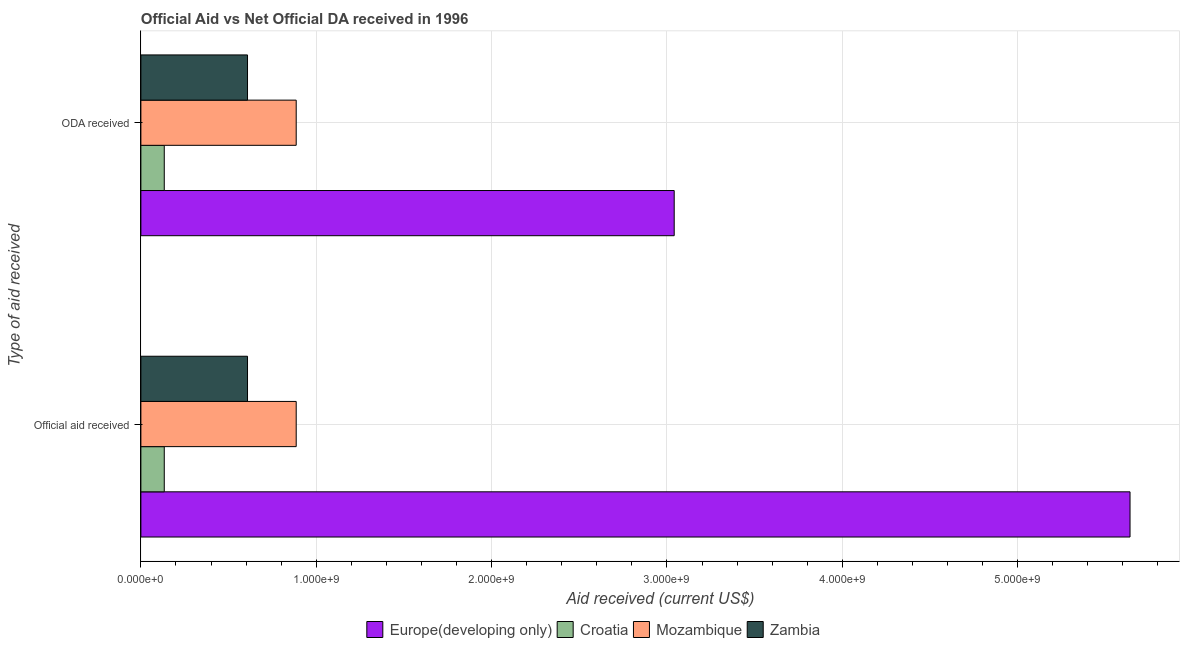How many different coloured bars are there?
Give a very brief answer. 4. Are the number of bars per tick equal to the number of legend labels?
Ensure brevity in your answer.  Yes. Are the number of bars on each tick of the Y-axis equal?
Ensure brevity in your answer.  Yes. How many bars are there on the 1st tick from the top?
Provide a short and direct response. 4. What is the label of the 1st group of bars from the top?
Offer a terse response. ODA received. What is the oda received in Croatia?
Provide a succinct answer. 1.33e+08. Across all countries, what is the maximum official aid received?
Keep it short and to the point. 5.64e+09. Across all countries, what is the minimum official aid received?
Provide a short and direct response. 1.33e+08. In which country was the official aid received maximum?
Your answer should be compact. Europe(developing only). In which country was the oda received minimum?
Provide a succinct answer. Croatia. What is the total official aid received in the graph?
Offer a terse response. 7.27e+09. What is the difference between the official aid received in Europe(developing only) and that in Zambia?
Keep it short and to the point. 5.03e+09. What is the difference between the oda received in Zambia and the official aid received in Croatia?
Your answer should be compact. 4.75e+08. What is the average oda received per country?
Your answer should be compact. 1.17e+09. In how many countries, is the oda received greater than 400000000 US$?
Make the answer very short. 3. What is the ratio of the oda received in Zambia to that in Europe(developing only)?
Your response must be concise. 0.2. Is the oda received in Croatia less than that in Mozambique?
Offer a terse response. Yes. What does the 2nd bar from the top in ODA received represents?
Your answer should be compact. Mozambique. What does the 1st bar from the bottom in ODA received represents?
Ensure brevity in your answer.  Europe(developing only). How many bars are there?
Make the answer very short. 8. Are the values on the major ticks of X-axis written in scientific E-notation?
Your answer should be compact. Yes. Does the graph contain any zero values?
Your response must be concise. No. Where does the legend appear in the graph?
Offer a very short reply. Bottom center. What is the title of the graph?
Provide a succinct answer. Official Aid vs Net Official DA received in 1996 . Does "Timor-Leste" appear as one of the legend labels in the graph?
Offer a terse response. No. What is the label or title of the X-axis?
Make the answer very short. Aid received (current US$). What is the label or title of the Y-axis?
Provide a short and direct response. Type of aid received. What is the Aid received (current US$) in Europe(developing only) in Official aid received?
Make the answer very short. 5.64e+09. What is the Aid received (current US$) of Croatia in Official aid received?
Provide a succinct answer. 1.33e+08. What is the Aid received (current US$) in Mozambique in Official aid received?
Make the answer very short. 8.86e+08. What is the Aid received (current US$) of Zambia in Official aid received?
Provide a succinct answer. 6.08e+08. What is the Aid received (current US$) in Europe(developing only) in ODA received?
Ensure brevity in your answer.  3.04e+09. What is the Aid received (current US$) of Croatia in ODA received?
Provide a short and direct response. 1.33e+08. What is the Aid received (current US$) in Mozambique in ODA received?
Give a very brief answer. 8.86e+08. What is the Aid received (current US$) in Zambia in ODA received?
Provide a succinct answer. 6.08e+08. Across all Type of aid received, what is the maximum Aid received (current US$) in Europe(developing only)?
Ensure brevity in your answer.  5.64e+09. Across all Type of aid received, what is the maximum Aid received (current US$) of Croatia?
Give a very brief answer. 1.33e+08. Across all Type of aid received, what is the maximum Aid received (current US$) in Mozambique?
Your answer should be compact. 8.86e+08. Across all Type of aid received, what is the maximum Aid received (current US$) of Zambia?
Offer a very short reply. 6.08e+08. Across all Type of aid received, what is the minimum Aid received (current US$) of Europe(developing only)?
Make the answer very short. 3.04e+09. Across all Type of aid received, what is the minimum Aid received (current US$) of Croatia?
Offer a terse response. 1.33e+08. Across all Type of aid received, what is the minimum Aid received (current US$) in Mozambique?
Provide a succinct answer. 8.86e+08. Across all Type of aid received, what is the minimum Aid received (current US$) of Zambia?
Your response must be concise. 6.08e+08. What is the total Aid received (current US$) of Europe(developing only) in the graph?
Offer a very short reply. 8.68e+09. What is the total Aid received (current US$) of Croatia in the graph?
Offer a very short reply. 2.67e+08. What is the total Aid received (current US$) of Mozambique in the graph?
Provide a succinct answer. 1.77e+09. What is the total Aid received (current US$) of Zambia in the graph?
Your answer should be very brief. 1.22e+09. What is the difference between the Aid received (current US$) in Europe(developing only) in Official aid received and that in ODA received?
Give a very brief answer. 2.60e+09. What is the difference between the Aid received (current US$) of Croatia in Official aid received and that in ODA received?
Provide a succinct answer. 0. What is the difference between the Aid received (current US$) in Mozambique in Official aid received and that in ODA received?
Your answer should be compact. 0. What is the difference between the Aid received (current US$) in Europe(developing only) in Official aid received and the Aid received (current US$) in Croatia in ODA received?
Offer a very short reply. 5.51e+09. What is the difference between the Aid received (current US$) in Europe(developing only) in Official aid received and the Aid received (current US$) in Mozambique in ODA received?
Your response must be concise. 4.76e+09. What is the difference between the Aid received (current US$) of Europe(developing only) in Official aid received and the Aid received (current US$) of Zambia in ODA received?
Give a very brief answer. 5.03e+09. What is the difference between the Aid received (current US$) of Croatia in Official aid received and the Aid received (current US$) of Mozambique in ODA received?
Provide a short and direct response. -7.52e+08. What is the difference between the Aid received (current US$) in Croatia in Official aid received and the Aid received (current US$) in Zambia in ODA received?
Provide a short and direct response. -4.75e+08. What is the difference between the Aid received (current US$) of Mozambique in Official aid received and the Aid received (current US$) of Zambia in ODA received?
Offer a terse response. 2.78e+08. What is the average Aid received (current US$) in Europe(developing only) per Type of aid received?
Make the answer very short. 4.34e+09. What is the average Aid received (current US$) in Croatia per Type of aid received?
Provide a succinct answer. 1.33e+08. What is the average Aid received (current US$) in Mozambique per Type of aid received?
Offer a very short reply. 8.86e+08. What is the average Aid received (current US$) of Zambia per Type of aid received?
Your answer should be very brief. 6.08e+08. What is the difference between the Aid received (current US$) of Europe(developing only) and Aid received (current US$) of Croatia in Official aid received?
Make the answer very short. 5.51e+09. What is the difference between the Aid received (current US$) of Europe(developing only) and Aid received (current US$) of Mozambique in Official aid received?
Provide a short and direct response. 4.76e+09. What is the difference between the Aid received (current US$) of Europe(developing only) and Aid received (current US$) of Zambia in Official aid received?
Give a very brief answer. 5.03e+09. What is the difference between the Aid received (current US$) of Croatia and Aid received (current US$) of Mozambique in Official aid received?
Provide a succinct answer. -7.52e+08. What is the difference between the Aid received (current US$) of Croatia and Aid received (current US$) of Zambia in Official aid received?
Keep it short and to the point. -4.75e+08. What is the difference between the Aid received (current US$) of Mozambique and Aid received (current US$) of Zambia in Official aid received?
Ensure brevity in your answer.  2.78e+08. What is the difference between the Aid received (current US$) of Europe(developing only) and Aid received (current US$) of Croatia in ODA received?
Keep it short and to the point. 2.91e+09. What is the difference between the Aid received (current US$) in Europe(developing only) and Aid received (current US$) in Mozambique in ODA received?
Provide a succinct answer. 2.16e+09. What is the difference between the Aid received (current US$) of Europe(developing only) and Aid received (current US$) of Zambia in ODA received?
Ensure brevity in your answer.  2.43e+09. What is the difference between the Aid received (current US$) in Croatia and Aid received (current US$) in Mozambique in ODA received?
Provide a short and direct response. -7.52e+08. What is the difference between the Aid received (current US$) in Croatia and Aid received (current US$) in Zambia in ODA received?
Provide a short and direct response. -4.75e+08. What is the difference between the Aid received (current US$) of Mozambique and Aid received (current US$) of Zambia in ODA received?
Offer a very short reply. 2.78e+08. What is the ratio of the Aid received (current US$) of Europe(developing only) in Official aid received to that in ODA received?
Keep it short and to the point. 1.85. What is the ratio of the Aid received (current US$) in Mozambique in Official aid received to that in ODA received?
Provide a short and direct response. 1. What is the difference between the highest and the second highest Aid received (current US$) in Europe(developing only)?
Keep it short and to the point. 2.60e+09. What is the difference between the highest and the lowest Aid received (current US$) in Europe(developing only)?
Give a very brief answer. 2.60e+09. 